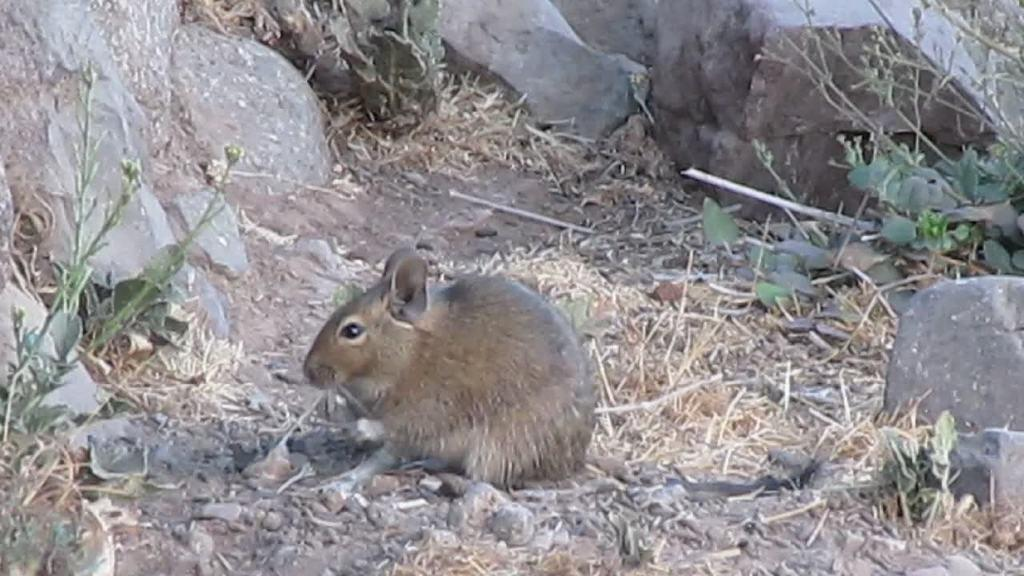What animal is on the ground in the image? There is a rat on the ground in the image. What type of natural elements can be seen in the image? There are stones and leaves visible in the image. How many children are playing with the spy equipment in the image? There are no children or spy equipment present in the image. 